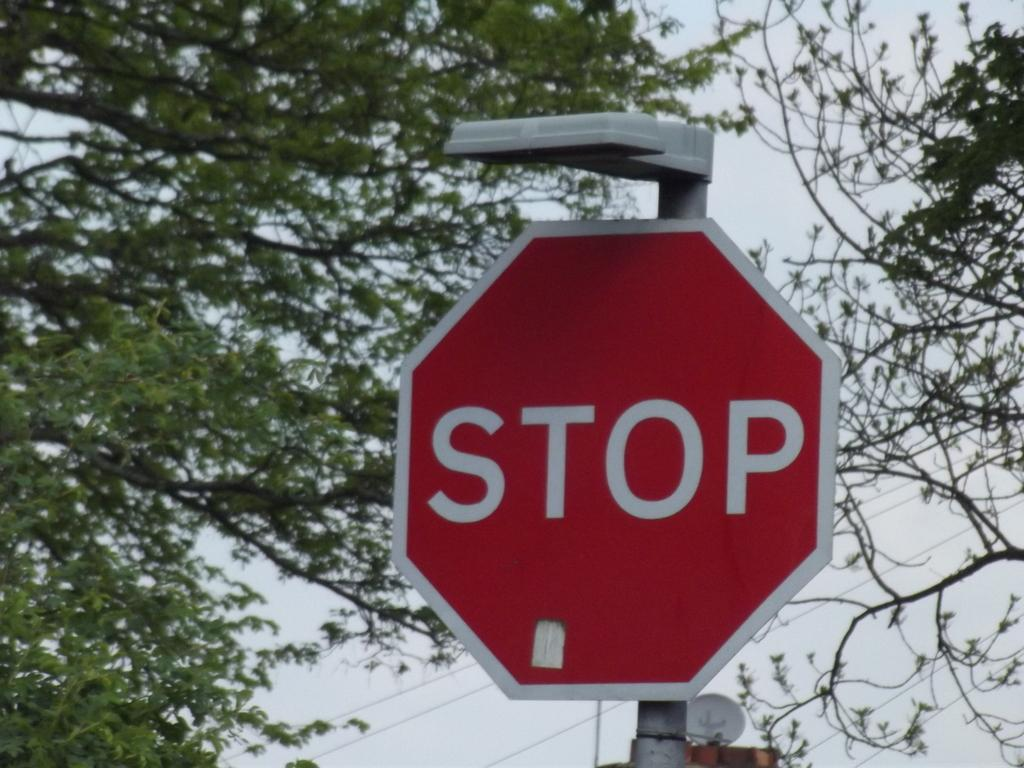<image>
Write a terse but informative summary of the picture. A red and white octogan that has the wording stop on it. 